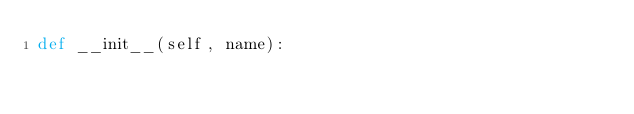<code> <loc_0><loc_0><loc_500><loc_500><_Python_>def __init__(self, name):
	</code> 